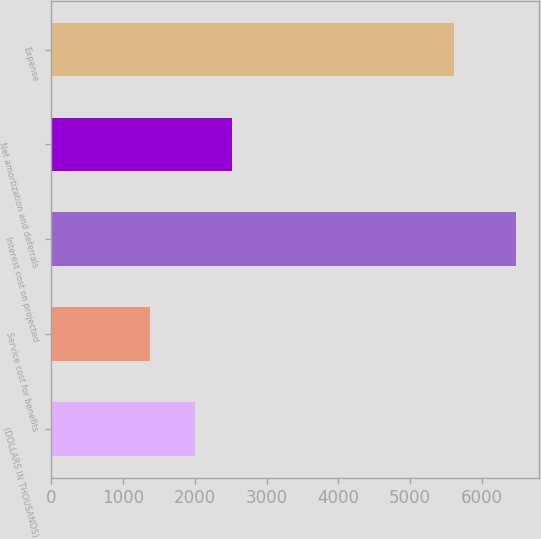Convert chart to OTSL. <chart><loc_0><loc_0><loc_500><loc_500><bar_chart><fcel>(DOLLARS IN THOUSANDS)<fcel>Service cost for benefits<fcel>Interest cost on projected<fcel>Net amortization and deferrals<fcel>Expense<nl><fcel>2010<fcel>1378<fcel>6468<fcel>2519<fcel>5614<nl></chart> 